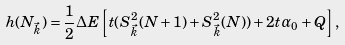Convert formula to latex. <formula><loc_0><loc_0><loc_500><loc_500>h ( N _ { \vec { k } } ) = \frac { 1 } { 2 } \Delta E \left [ t ( S ^ { 2 } _ { \vec { k } } ( N + 1 ) + S ^ { 2 } _ { \vec { k } } ( N ) ) + 2 t \alpha _ { 0 } + Q \right ] ,</formula> 